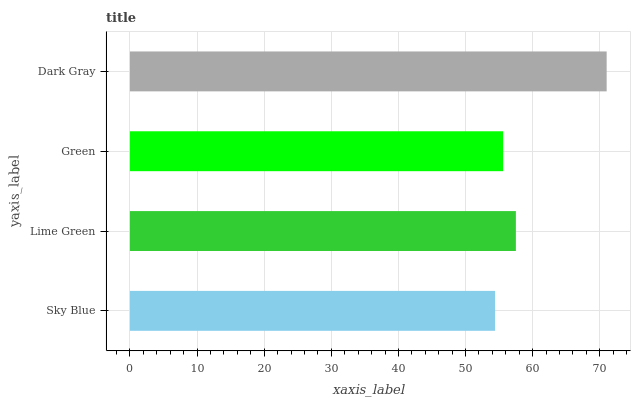Is Sky Blue the minimum?
Answer yes or no. Yes. Is Dark Gray the maximum?
Answer yes or no. Yes. Is Lime Green the minimum?
Answer yes or no. No. Is Lime Green the maximum?
Answer yes or no. No. Is Lime Green greater than Sky Blue?
Answer yes or no. Yes. Is Sky Blue less than Lime Green?
Answer yes or no. Yes. Is Sky Blue greater than Lime Green?
Answer yes or no. No. Is Lime Green less than Sky Blue?
Answer yes or no. No. Is Lime Green the high median?
Answer yes or no. Yes. Is Green the low median?
Answer yes or no. Yes. Is Dark Gray the high median?
Answer yes or no. No. Is Lime Green the low median?
Answer yes or no. No. 